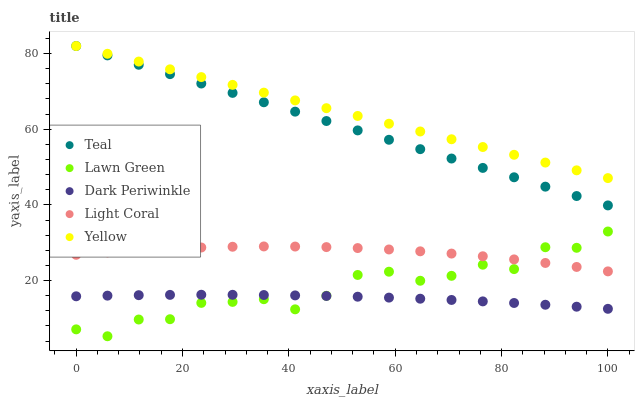Does Dark Periwinkle have the minimum area under the curve?
Answer yes or no. Yes. Does Yellow have the maximum area under the curve?
Answer yes or no. Yes. Does Lawn Green have the minimum area under the curve?
Answer yes or no. No. Does Lawn Green have the maximum area under the curve?
Answer yes or no. No. Is Teal the smoothest?
Answer yes or no. Yes. Is Lawn Green the roughest?
Answer yes or no. Yes. Is Yellow the smoothest?
Answer yes or no. No. Is Yellow the roughest?
Answer yes or no. No. Does Lawn Green have the lowest value?
Answer yes or no. Yes. Does Yellow have the lowest value?
Answer yes or no. No. Does Teal have the highest value?
Answer yes or no. Yes. Does Lawn Green have the highest value?
Answer yes or no. No. Is Light Coral less than Teal?
Answer yes or no. Yes. Is Yellow greater than Lawn Green?
Answer yes or no. Yes. Does Teal intersect Yellow?
Answer yes or no. Yes. Is Teal less than Yellow?
Answer yes or no. No. Is Teal greater than Yellow?
Answer yes or no. No. Does Light Coral intersect Teal?
Answer yes or no. No. 